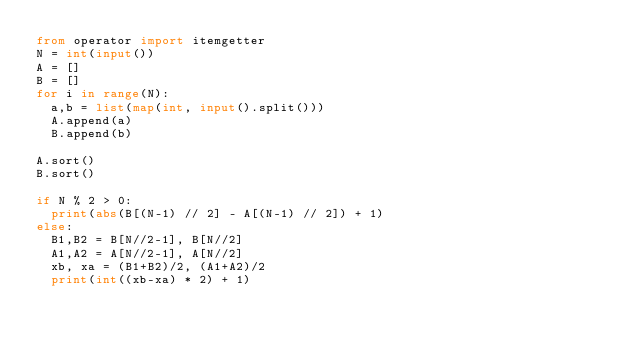Convert code to text. <code><loc_0><loc_0><loc_500><loc_500><_Python_>from operator import itemgetter
N = int(input())
A = []
B = []
for i in range(N):
  a,b = list(map(int, input().split()))
  A.append(a)
  B.append(b)

A.sort()
B.sort()

if N % 2 > 0:
  print(abs(B[(N-1) // 2] - A[(N-1) // 2]) + 1)
else:
  B1,B2 = B[N//2-1], B[N//2]
  A1,A2 = A[N//2-1], A[N//2]
  xb, xa = (B1+B2)/2, (A1+A2)/2
  print(int((xb-xa) * 2) + 1)

</code> 